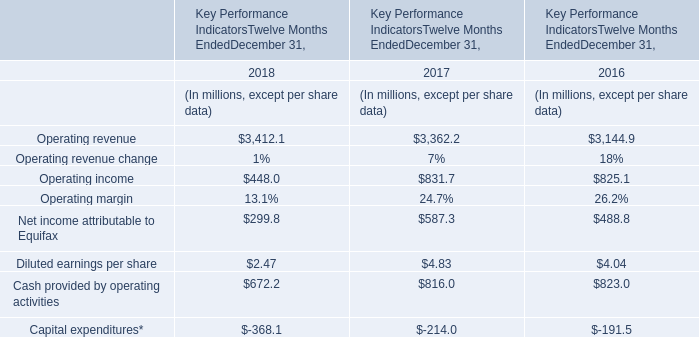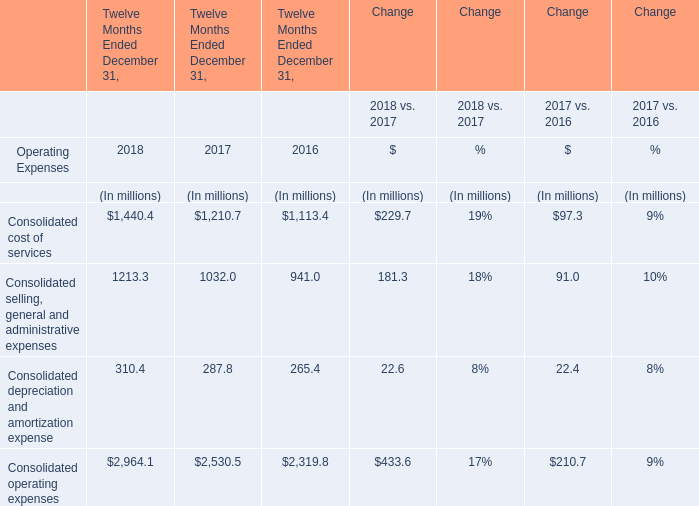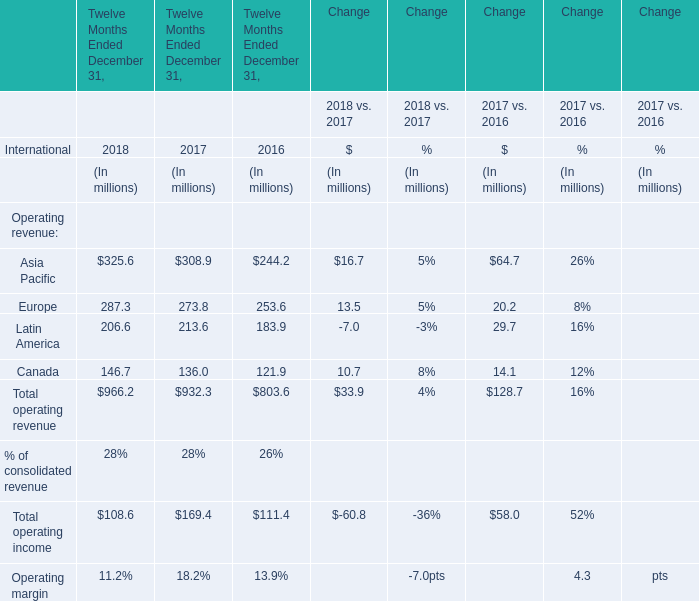What is the ratio of Europe in Table 2 to the Consolidated selling, general and administrative expenses in Table 1 in 2016? 
Computations: (253.6 / 941)
Answer: 0.2695. 